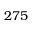<formula> <loc_0><loc_0><loc_500><loc_500>2 7 5</formula> 